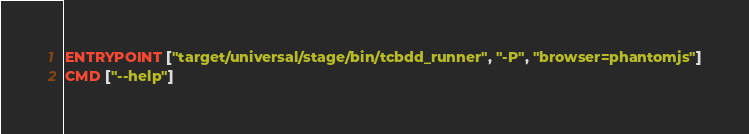<code> <loc_0><loc_0><loc_500><loc_500><_Dockerfile_>
ENTRYPOINT ["target/universal/stage/bin/tcbdd_runner", "-P", "browser=phantomjs"]
CMD ["--help"]</code> 